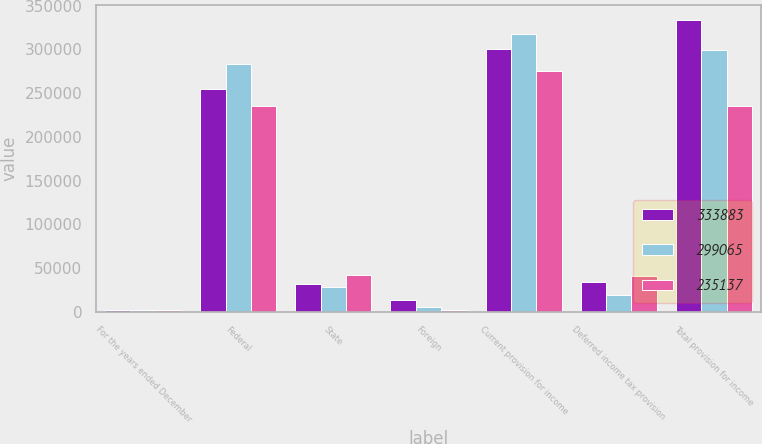Convert chart. <chart><loc_0><loc_0><loc_500><loc_500><stacked_bar_chart><ecel><fcel>For the years ended December<fcel>Federal<fcel>State<fcel>Foreign<fcel>Current provision for income<fcel>Deferred income tax provision<fcel>Total provision for income<nl><fcel>333883<fcel>2011<fcel>254732<fcel>32174<fcel>13366<fcel>300272<fcel>33611<fcel>333883<nl><fcel>299065<fcel>2010<fcel>283449<fcel>28423<fcel>5847<fcel>317719<fcel>18654<fcel>299065<nl><fcel>235137<fcel>2009<fcel>235282<fcel>42206<fcel>1773<fcel>275715<fcel>40578<fcel>235137<nl></chart> 